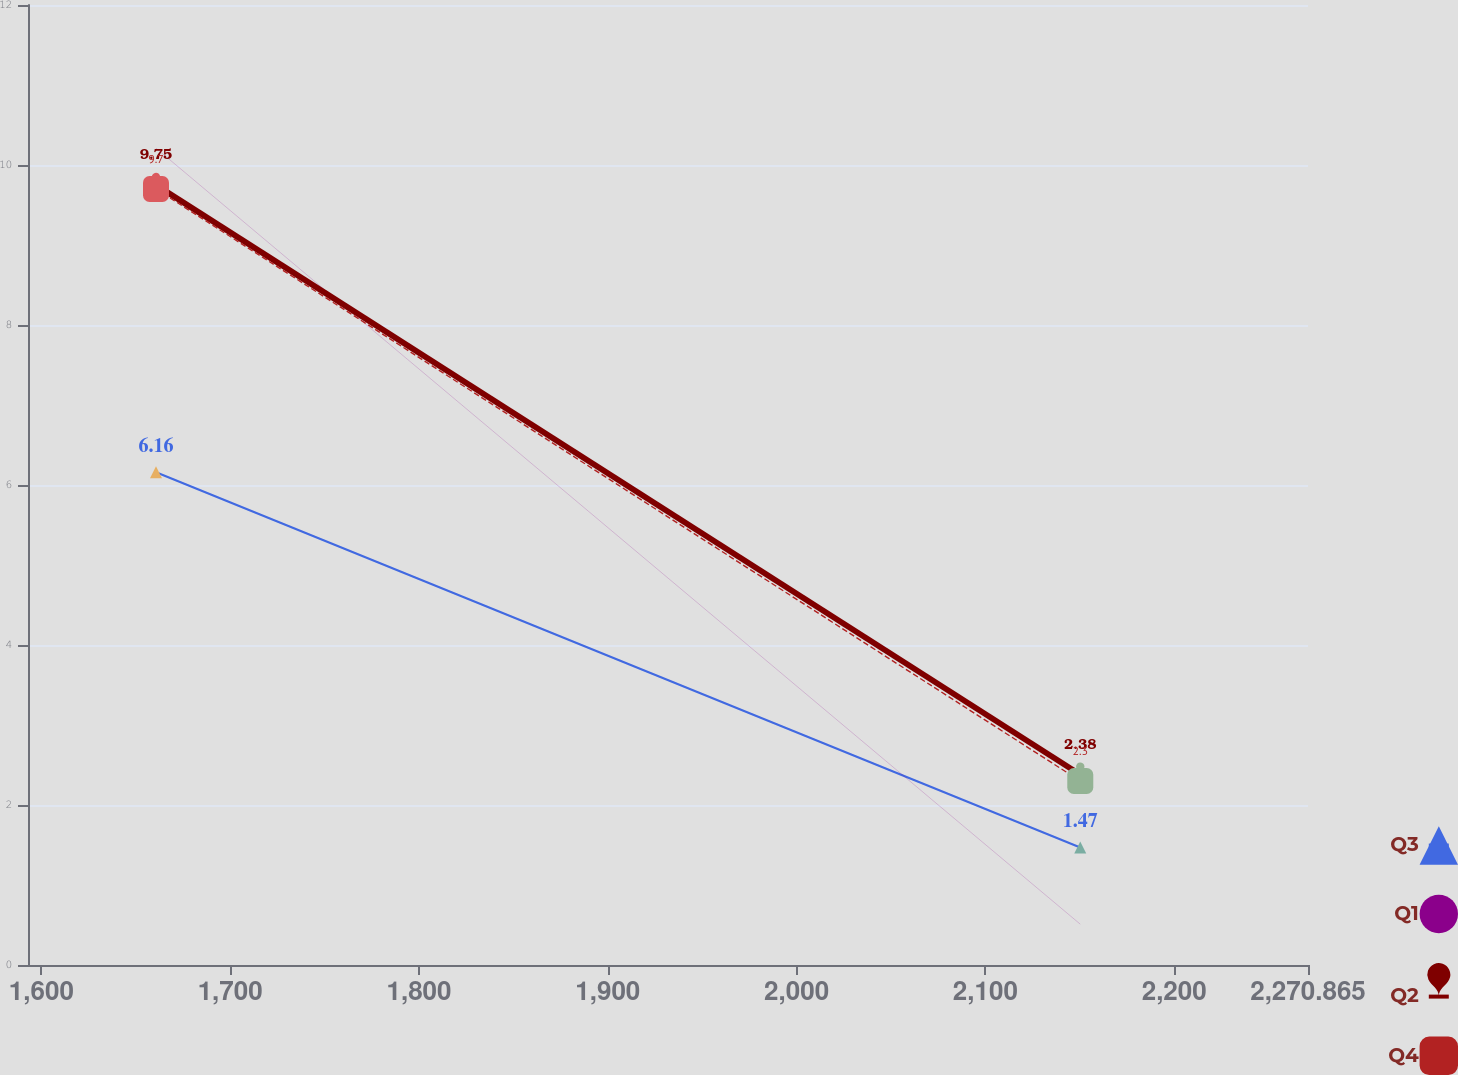Convert chart. <chart><loc_0><loc_0><loc_500><loc_500><line_chart><ecel><fcel>Q3<fcel>Q1<fcel>Q2<fcel>Q4<nl><fcel>1660.71<fcel>6.16<fcel>10.21<fcel>9.75<fcel>9.7<nl><fcel>2150.25<fcel>1.47<fcel>0.51<fcel>2.38<fcel>2.3<nl><fcel>2338.66<fcel>9.75<fcel>5.92<fcel>0.1<fcel>3.04<nl></chart> 